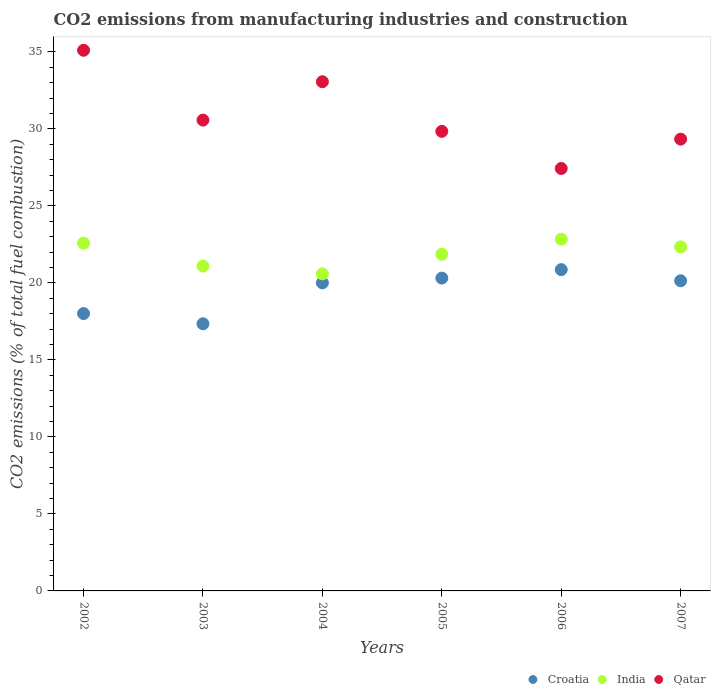How many different coloured dotlines are there?
Your answer should be very brief. 3. What is the amount of CO2 emitted in Croatia in 2002?
Provide a short and direct response. 18.01. Across all years, what is the maximum amount of CO2 emitted in Croatia?
Make the answer very short. 20.86. Across all years, what is the minimum amount of CO2 emitted in Croatia?
Your response must be concise. 17.34. What is the total amount of CO2 emitted in India in the graph?
Provide a short and direct response. 131.28. What is the difference between the amount of CO2 emitted in Qatar in 2006 and that in 2007?
Give a very brief answer. -1.91. What is the difference between the amount of CO2 emitted in India in 2004 and the amount of CO2 emitted in Qatar in 2005?
Your answer should be compact. -9.25. What is the average amount of CO2 emitted in Croatia per year?
Keep it short and to the point. 19.44. In the year 2006, what is the difference between the amount of CO2 emitted in India and amount of CO2 emitted in Croatia?
Provide a short and direct response. 1.98. In how many years, is the amount of CO2 emitted in Qatar greater than 15 %?
Provide a succinct answer. 6. What is the ratio of the amount of CO2 emitted in Qatar in 2005 to that in 2007?
Your answer should be very brief. 1.02. What is the difference between the highest and the second highest amount of CO2 emitted in India?
Your answer should be compact. 0.26. What is the difference between the highest and the lowest amount of CO2 emitted in India?
Keep it short and to the point. 2.25. Does the amount of CO2 emitted in Croatia monotonically increase over the years?
Ensure brevity in your answer.  No. How many dotlines are there?
Make the answer very short. 3. Are the values on the major ticks of Y-axis written in scientific E-notation?
Your answer should be compact. No. Does the graph contain grids?
Your answer should be very brief. No. Where does the legend appear in the graph?
Your answer should be compact. Bottom right. How many legend labels are there?
Make the answer very short. 3. How are the legend labels stacked?
Your response must be concise. Horizontal. What is the title of the graph?
Your response must be concise. CO2 emissions from manufacturing industries and construction. What is the label or title of the Y-axis?
Offer a terse response. CO2 emissions (% of total fuel combustion). What is the CO2 emissions (% of total fuel combustion) in Croatia in 2002?
Keep it short and to the point. 18.01. What is the CO2 emissions (% of total fuel combustion) of India in 2002?
Your answer should be very brief. 22.58. What is the CO2 emissions (% of total fuel combustion) in Qatar in 2002?
Your response must be concise. 35.1. What is the CO2 emissions (% of total fuel combustion) in Croatia in 2003?
Give a very brief answer. 17.34. What is the CO2 emissions (% of total fuel combustion) in India in 2003?
Provide a succinct answer. 21.09. What is the CO2 emissions (% of total fuel combustion) in Qatar in 2003?
Your response must be concise. 30.57. What is the CO2 emissions (% of total fuel combustion) of India in 2004?
Provide a short and direct response. 20.59. What is the CO2 emissions (% of total fuel combustion) in Qatar in 2004?
Give a very brief answer. 33.06. What is the CO2 emissions (% of total fuel combustion) in Croatia in 2005?
Offer a very short reply. 20.31. What is the CO2 emissions (% of total fuel combustion) in India in 2005?
Provide a short and direct response. 21.86. What is the CO2 emissions (% of total fuel combustion) in Qatar in 2005?
Your answer should be compact. 29.84. What is the CO2 emissions (% of total fuel combustion) in Croatia in 2006?
Your answer should be compact. 20.86. What is the CO2 emissions (% of total fuel combustion) in India in 2006?
Provide a succinct answer. 22.84. What is the CO2 emissions (% of total fuel combustion) in Qatar in 2006?
Your response must be concise. 27.42. What is the CO2 emissions (% of total fuel combustion) of Croatia in 2007?
Provide a succinct answer. 20.14. What is the CO2 emissions (% of total fuel combustion) in India in 2007?
Keep it short and to the point. 22.33. What is the CO2 emissions (% of total fuel combustion) of Qatar in 2007?
Provide a short and direct response. 29.33. Across all years, what is the maximum CO2 emissions (% of total fuel combustion) of Croatia?
Provide a succinct answer. 20.86. Across all years, what is the maximum CO2 emissions (% of total fuel combustion) in India?
Give a very brief answer. 22.84. Across all years, what is the maximum CO2 emissions (% of total fuel combustion) of Qatar?
Provide a short and direct response. 35.1. Across all years, what is the minimum CO2 emissions (% of total fuel combustion) in Croatia?
Provide a succinct answer. 17.34. Across all years, what is the minimum CO2 emissions (% of total fuel combustion) in India?
Provide a succinct answer. 20.59. Across all years, what is the minimum CO2 emissions (% of total fuel combustion) of Qatar?
Offer a very short reply. 27.42. What is the total CO2 emissions (% of total fuel combustion) of Croatia in the graph?
Offer a terse response. 116.65. What is the total CO2 emissions (% of total fuel combustion) in India in the graph?
Ensure brevity in your answer.  131.28. What is the total CO2 emissions (% of total fuel combustion) in Qatar in the graph?
Your answer should be very brief. 185.32. What is the difference between the CO2 emissions (% of total fuel combustion) of Croatia in 2002 and that in 2003?
Ensure brevity in your answer.  0.66. What is the difference between the CO2 emissions (% of total fuel combustion) of India in 2002 and that in 2003?
Provide a succinct answer. 1.49. What is the difference between the CO2 emissions (% of total fuel combustion) in Qatar in 2002 and that in 2003?
Ensure brevity in your answer.  4.53. What is the difference between the CO2 emissions (% of total fuel combustion) of Croatia in 2002 and that in 2004?
Offer a terse response. -1.99. What is the difference between the CO2 emissions (% of total fuel combustion) in India in 2002 and that in 2004?
Keep it short and to the point. 1.99. What is the difference between the CO2 emissions (% of total fuel combustion) of Qatar in 2002 and that in 2004?
Make the answer very short. 2.04. What is the difference between the CO2 emissions (% of total fuel combustion) of Croatia in 2002 and that in 2005?
Offer a terse response. -2.3. What is the difference between the CO2 emissions (% of total fuel combustion) in India in 2002 and that in 2005?
Offer a very short reply. 0.72. What is the difference between the CO2 emissions (% of total fuel combustion) of Qatar in 2002 and that in 2005?
Offer a very short reply. 5.27. What is the difference between the CO2 emissions (% of total fuel combustion) of Croatia in 2002 and that in 2006?
Provide a succinct answer. -2.85. What is the difference between the CO2 emissions (% of total fuel combustion) of India in 2002 and that in 2006?
Keep it short and to the point. -0.26. What is the difference between the CO2 emissions (% of total fuel combustion) of Qatar in 2002 and that in 2006?
Your answer should be compact. 7.68. What is the difference between the CO2 emissions (% of total fuel combustion) of Croatia in 2002 and that in 2007?
Offer a very short reply. -2.13. What is the difference between the CO2 emissions (% of total fuel combustion) of India in 2002 and that in 2007?
Provide a short and direct response. 0.24. What is the difference between the CO2 emissions (% of total fuel combustion) in Qatar in 2002 and that in 2007?
Your response must be concise. 5.77. What is the difference between the CO2 emissions (% of total fuel combustion) of Croatia in 2003 and that in 2004?
Make the answer very short. -2.66. What is the difference between the CO2 emissions (% of total fuel combustion) in India in 2003 and that in 2004?
Provide a succinct answer. 0.5. What is the difference between the CO2 emissions (% of total fuel combustion) of Qatar in 2003 and that in 2004?
Provide a short and direct response. -2.49. What is the difference between the CO2 emissions (% of total fuel combustion) of Croatia in 2003 and that in 2005?
Ensure brevity in your answer.  -2.97. What is the difference between the CO2 emissions (% of total fuel combustion) in India in 2003 and that in 2005?
Keep it short and to the point. -0.77. What is the difference between the CO2 emissions (% of total fuel combustion) of Qatar in 2003 and that in 2005?
Your answer should be compact. 0.73. What is the difference between the CO2 emissions (% of total fuel combustion) in Croatia in 2003 and that in 2006?
Your response must be concise. -3.51. What is the difference between the CO2 emissions (% of total fuel combustion) in India in 2003 and that in 2006?
Give a very brief answer. -1.75. What is the difference between the CO2 emissions (% of total fuel combustion) of Qatar in 2003 and that in 2006?
Keep it short and to the point. 3.14. What is the difference between the CO2 emissions (% of total fuel combustion) of Croatia in 2003 and that in 2007?
Offer a terse response. -2.79. What is the difference between the CO2 emissions (% of total fuel combustion) in India in 2003 and that in 2007?
Ensure brevity in your answer.  -1.25. What is the difference between the CO2 emissions (% of total fuel combustion) in Qatar in 2003 and that in 2007?
Your response must be concise. 1.24. What is the difference between the CO2 emissions (% of total fuel combustion) in Croatia in 2004 and that in 2005?
Ensure brevity in your answer.  -0.31. What is the difference between the CO2 emissions (% of total fuel combustion) in India in 2004 and that in 2005?
Your answer should be compact. -1.27. What is the difference between the CO2 emissions (% of total fuel combustion) of Qatar in 2004 and that in 2005?
Give a very brief answer. 3.22. What is the difference between the CO2 emissions (% of total fuel combustion) of Croatia in 2004 and that in 2006?
Your answer should be compact. -0.86. What is the difference between the CO2 emissions (% of total fuel combustion) of India in 2004 and that in 2006?
Your answer should be very brief. -2.25. What is the difference between the CO2 emissions (% of total fuel combustion) in Qatar in 2004 and that in 2006?
Ensure brevity in your answer.  5.63. What is the difference between the CO2 emissions (% of total fuel combustion) in Croatia in 2004 and that in 2007?
Your answer should be very brief. -0.14. What is the difference between the CO2 emissions (% of total fuel combustion) in India in 2004 and that in 2007?
Offer a very short reply. -1.75. What is the difference between the CO2 emissions (% of total fuel combustion) of Qatar in 2004 and that in 2007?
Your response must be concise. 3.73. What is the difference between the CO2 emissions (% of total fuel combustion) of Croatia in 2005 and that in 2006?
Ensure brevity in your answer.  -0.55. What is the difference between the CO2 emissions (% of total fuel combustion) of India in 2005 and that in 2006?
Your answer should be compact. -0.98. What is the difference between the CO2 emissions (% of total fuel combustion) in Qatar in 2005 and that in 2006?
Make the answer very short. 2.41. What is the difference between the CO2 emissions (% of total fuel combustion) of Croatia in 2005 and that in 2007?
Make the answer very short. 0.17. What is the difference between the CO2 emissions (% of total fuel combustion) of India in 2005 and that in 2007?
Provide a succinct answer. -0.48. What is the difference between the CO2 emissions (% of total fuel combustion) in Qatar in 2005 and that in 2007?
Your answer should be compact. 0.5. What is the difference between the CO2 emissions (% of total fuel combustion) of Croatia in 2006 and that in 2007?
Provide a short and direct response. 0.72. What is the difference between the CO2 emissions (% of total fuel combustion) of India in 2006 and that in 2007?
Keep it short and to the point. 0.5. What is the difference between the CO2 emissions (% of total fuel combustion) of Qatar in 2006 and that in 2007?
Provide a short and direct response. -1.91. What is the difference between the CO2 emissions (% of total fuel combustion) of Croatia in 2002 and the CO2 emissions (% of total fuel combustion) of India in 2003?
Make the answer very short. -3.08. What is the difference between the CO2 emissions (% of total fuel combustion) in Croatia in 2002 and the CO2 emissions (% of total fuel combustion) in Qatar in 2003?
Your answer should be very brief. -12.56. What is the difference between the CO2 emissions (% of total fuel combustion) in India in 2002 and the CO2 emissions (% of total fuel combustion) in Qatar in 2003?
Your response must be concise. -7.99. What is the difference between the CO2 emissions (% of total fuel combustion) in Croatia in 2002 and the CO2 emissions (% of total fuel combustion) in India in 2004?
Provide a succinct answer. -2.58. What is the difference between the CO2 emissions (% of total fuel combustion) of Croatia in 2002 and the CO2 emissions (% of total fuel combustion) of Qatar in 2004?
Make the answer very short. -15.05. What is the difference between the CO2 emissions (% of total fuel combustion) in India in 2002 and the CO2 emissions (% of total fuel combustion) in Qatar in 2004?
Keep it short and to the point. -10.48. What is the difference between the CO2 emissions (% of total fuel combustion) of Croatia in 2002 and the CO2 emissions (% of total fuel combustion) of India in 2005?
Offer a very short reply. -3.85. What is the difference between the CO2 emissions (% of total fuel combustion) in Croatia in 2002 and the CO2 emissions (% of total fuel combustion) in Qatar in 2005?
Ensure brevity in your answer.  -11.83. What is the difference between the CO2 emissions (% of total fuel combustion) in India in 2002 and the CO2 emissions (% of total fuel combustion) in Qatar in 2005?
Your response must be concise. -7.26. What is the difference between the CO2 emissions (% of total fuel combustion) in Croatia in 2002 and the CO2 emissions (% of total fuel combustion) in India in 2006?
Your answer should be very brief. -4.83. What is the difference between the CO2 emissions (% of total fuel combustion) in Croatia in 2002 and the CO2 emissions (% of total fuel combustion) in Qatar in 2006?
Your answer should be very brief. -9.42. What is the difference between the CO2 emissions (% of total fuel combustion) in India in 2002 and the CO2 emissions (% of total fuel combustion) in Qatar in 2006?
Your answer should be compact. -4.85. What is the difference between the CO2 emissions (% of total fuel combustion) of Croatia in 2002 and the CO2 emissions (% of total fuel combustion) of India in 2007?
Your response must be concise. -4.33. What is the difference between the CO2 emissions (% of total fuel combustion) of Croatia in 2002 and the CO2 emissions (% of total fuel combustion) of Qatar in 2007?
Keep it short and to the point. -11.33. What is the difference between the CO2 emissions (% of total fuel combustion) in India in 2002 and the CO2 emissions (% of total fuel combustion) in Qatar in 2007?
Give a very brief answer. -6.75. What is the difference between the CO2 emissions (% of total fuel combustion) in Croatia in 2003 and the CO2 emissions (% of total fuel combustion) in India in 2004?
Offer a very short reply. -3.24. What is the difference between the CO2 emissions (% of total fuel combustion) of Croatia in 2003 and the CO2 emissions (% of total fuel combustion) of Qatar in 2004?
Your response must be concise. -15.71. What is the difference between the CO2 emissions (% of total fuel combustion) in India in 2003 and the CO2 emissions (% of total fuel combustion) in Qatar in 2004?
Ensure brevity in your answer.  -11.97. What is the difference between the CO2 emissions (% of total fuel combustion) of Croatia in 2003 and the CO2 emissions (% of total fuel combustion) of India in 2005?
Offer a very short reply. -4.51. What is the difference between the CO2 emissions (% of total fuel combustion) in Croatia in 2003 and the CO2 emissions (% of total fuel combustion) in Qatar in 2005?
Provide a short and direct response. -12.49. What is the difference between the CO2 emissions (% of total fuel combustion) in India in 2003 and the CO2 emissions (% of total fuel combustion) in Qatar in 2005?
Your response must be concise. -8.75. What is the difference between the CO2 emissions (% of total fuel combustion) in Croatia in 2003 and the CO2 emissions (% of total fuel combustion) in India in 2006?
Provide a succinct answer. -5.49. What is the difference between the CO2 emissions (% of total fuel combustion) of Croatia in 2003 and the CO2 emissions (% of total fuel combustion) of Qatar in 2006?
Offer a very short reply. -10.08. What is the difference between the CO2 emissions (% of total fuel combustion) of India in 2003 and the CO2 emissions (% of total fuel combustion) of Qatar in 2006?
Keep it short and to the point. -6.34. What is the difference between the CO2 emissions (% of total fuel combustion) in Croatia in 2003 and the CO2 emissions (% of total fuel combustion) in India in 2007?
Your answer should be very brief. -4.99. What is the difference between the CO2 emissions (% of total fuel combustion) of Croatia in 2003 and the CO2 emissions (% of total fuel combustion) of Qatar in 2007?
Make the answer very short. -11.99. What is the difference between the CO2 emissions (% of total fuel combustion) of India in 2003 and the CO2 emissions (% of total fuel combustion) of Qatar in 2007?
Your answer should be compact. -8.24. What is the difference between the CO2 emissions (% of total fuel combustion) of Croatia in 2004 and the CO2 emissions (% of total fuel combustion) of India in 2005?
Offer a very short reply. -1.86. What is the difference between the CO2 emissions (% of total fuel combustion) in Croatia in 2004 and the CO2 emissions (% of total fuel combustion) in Qatar in 2005?
Give a very brief answer. -9.84. What is the difference between the CO2 emissions (% of total fuel combustion) of India in 2004 and the CO2 emissions (% of total fuel combustion) of Qatar in 2005?
Your answer should be very brief. -9.25. What is the difference between the CO2 emissions (% of total fuel combustion) in Croatia in 2004 and the CO2 emissions (% of total fuel combustion) in India in 2006?
Ensure brevity in your answer.  -2.84. What is the difference between the CO2 emissions (% of total fuel combustion) of Croatia in 2004 and the CO2 emissions (% of total fuel combustion) of Qatar in 2006?
Your answer should be very brief. -7.42. What is the difference between the CO2 emissions (% of total fuel combustion) in India in 2004 and the CO2 emissions (% of total fuel combustion) in Qatar in 2006?
Your response must be concise. -6.84. What is the difference between the CO2 emissions (% of total fuel combustion) of Croatia in 2004 and the CO2 emissions (% of total fuel combustion) of India in 2007?
Ensure brevity in your answer.  -2.33. What is the difference between the CO2 emissions (% of total fuel combustion) of Croatia in 2004 and the CO2 emissions (% of total fuel combustion) of Qatar in 2007?
Your answer should be compact. -9.33. What is the difference between the CO2 emissions (% of total fuel combustion) in India in 2004 and the CO2 emissions (% of total fuel combustion) in Qatar in 2007?
Provide a succinct answer. -8.75. What is the difference between the CO2 emissions (% of total fuel combustion) of Croatia in 2005 and the CO2 emissions (% of total fuel combustion) of India in 2006?
Provide a succinct answer. -2.53. What is the difference between the CO2 emissions (% of total fuel combustion) of Croatia in 2005 and the CO2 emissions (% of total fuel combustion) of Qatar in 2006?
Ensure brevity in your answer.  -7.12. What is the difference between the CO2 emissions (% of total fuel combustion) of India in 2005 and the CO2 emissions (% of total fuel combustion) of Qatar in 2006?
Your answer should be very brief. -5.57. What is the difference between the CO2 emissions (% of total fuel combustion) of Croatia in 2005 and the CO2 emissions (% of total fuel combustion) of India in 2007?
Give a very brief answer. -2.03. What is the difference between the CO2 emissions (% of total fuel combustion) of Croatia in 2005 and the CO2 emissions (% of total fuel combustion) of Qatar in 2007?
Your answer should be very brief. -9.02. What is the difference between the CO2 emissions (% of total fuel combustion) in India in 2005 and the CO2 emissions (% of total fuel combustion) in Qatar in 2007?
Make the answer very short. -7.47. What is the difference between the CO2 emissions (% of total fuel combustion) of Croatia in 2006 and the CO2 emissions (% of total fuel combustion) of India in 2007?
Offer a very short reply. -1.48. What is the difference between the CO2 emissions (% of total fuel combustion) in Croatia in 2006 and the CO2 emissions (% of total fuel combustion) in Qatar in 2007?
Provide a short and direct response. -8.47. What is the difference between the CO2 emissions (% of total fuel combustion) in India in 2006 and the CO2 emissions (% of total fuel combustion) in Qatar in 2007?
Keep it short and to the point. -6.5. What is the average CO2 emissions (% of total fuel combustion) of Croatia per year?
Offer a terse response. 19.44. What is the average CO2 emissions (% of total fuel combustion) in India per year?
Ensure brevity in your answer.  21.88. What is the average CO2 emissions (% of total fuel combustion) of Qatar per year?
Your answer should be compact. 30.89. In the year 2002, what is the difference between the CO2 emissions (% of total fuel combustion) in Croatia and CO2 emissions (% of total fuel combustion) in India?
Give a very brief answer. -4.57. In the year 2002, what is the difference between the CO2 emissions (% of total fuel combustion) in Croatia and CO2 emissions (% of total fuel combustion) in Qatar?
Offer a very short reply. -17.1. In the year 2002, what is the difference between the CO2 emissions (% of total fuel combustion) of India and CO2 emissions (% of total fuel combustion) of Qatar?
Make the answer very short. -12.52. In the year 2003, what is the difference between the CO2 emissions (% of total fuel combustion) of Croatia and CO2 emissions (% of total fuel combustion) of India?
Your answer should be compact. -3.74. In the year 2003, what is the difference between the CO2 emissions (% of total fuel combustion) in Croatia and CO2 emissions (% of total fuel combustion) in Qatar?
Offer a very short reply. -13.22. In the year 2003, what is the difference between the CO2 emissions (% of total fuel combustion) in India and CO2 emissions (% of total fuel combustion) in Qatar?
Make the answer very short. -9.48. In the year 2004, what is the difference between the CO2 emissions (% of total fuel combustion) in Croatia and CO2 emissions (% of total fuel combustion) in India?
Provide a succinct answer. -0.59. In the year 2004, what is the difference between the CO2 emissions (% of total fuel combustion) of Croatia and CO2 emissions (% of total fuel combustion) of Qatar?
Your answer should be very brief. -13.06. In the year 2004, what is the difference between the CO2 emissions (% of total fuel combustion) in India and CO2 emissions (% of total fuel combustion) in Qatar?
Your answer should be compact. -12.47. In the year 2005, what is the difference between the CO2 emissions (% of total fuel combustion) of Croatia and CO2 emissions (% of total fuel combustion) of India?
Offer a very short reply. -1.55. In the year 2005, what is the difference between the CO2 emissions (% of total fuel combustion) in Croatia and CO2 emissions (% of total fuel combustion) in Qatar?
Provide a short and direct response. -9.53. In the year 2005, what is the difference between the CO2 emissions (% of total fuel combustion) in India and CO2 emissions (% of total fuel combustion) in Qatar?
Provide a short and direct response. -7.98. In the year 2006, what is the difference between the CO2 emissions (% of total fuel combustion) of Croatia and CO2 emissions (% of total fuel combustion) of India?
Provide a short and direct response. -1.98. In the year 2006, what is the difference between the CO2 emissions (% of total fuel combustion) in Croatia and CO2 emissions (% of total fuel combustion) in Qatar?
Offer a terse response. -6.57. In the year 2006, what is the difference between the CO2 emissions (% of total fuel combustion) of India and CO2 emissions (% of total fuel combustion) of Qatar?
Give a very brief answer. -4.59. In the year 2007, what is the difference between the CO2 emissions (% of total fuel combustion) of Croatia and CO2 emissions (% of total fuel combustion) of India?
Provide a succinct answer. -2.2. In the year 2007, what is the difference between the CO2 emissions (% of total fuel combustion) of Croatia and CO2 emissions (% of total fuel combustion) of Qatar?
Make the answer very short. -9.2. In the year 2007, what is the difference between the CO2 emissions (% of total fuel combustion) in India and CO2 emissions (% of total fuel combustion) in Qatar?
Provide a short and direct response. -7. What is the ratio of the CO2 emissions (% of total fuel combustion) in Croatia in 2002 to that in 2003?
Your answer should be very brief. 1.04. What is the ratio of the CO2 emissions (% of total fuel combustion) in India in 2002 to that in 2003?
Provide a succinct answer. 1.07. What is the ratio of the CO2 emissions (% of total fuel combustion) in Qatar in 2002 to that in 2003?
Offer a terse response. 1.15. What is the ratio of the CO2 emissions (% of total fuel combustion) in Croatia in 2002 to that in 2004?
Provide a short and direct response. 0.9. What is the ratio of the CO2 emissions (% of total fuel combustion) of India in 2002 to that in 2004?
Give a very brief answer. 1.1. What is the ratio of the CO2 emissions (% of total fuel combustion) of Qatar in 2002 to that in 2004?
Provide a succinct answer. 1.06. What is the ratio of the CO2 emissions (% of total fuel combustion) of Croatia in 2002 to that in 2005?
Offer a very short reply. 0.89. What is the ratio of the CO2 emissions (% of total fuel combustion) in India in 2002 to that in 2005?
Your answer should be compact. 1.03. What is the ratio of the CO2 emissions (% of total fuel combustion) in Qatar in 2002 to that in 2005?
Offer a very short reply. 1.18. What is the ratio of the CO2 emissions (% of total fuel combustion) of Croatia in 2002 to that in 2006?
Keep it short and to the point. 0.86. What is the ratio of the CO2 emissions (% of total fuel combustion) of India in 2002 to that in 2006?
Your answer should be compact. 0.99. What is the ratio of the CO2 emissions (% of total fuel combustion) in Qatar in 2002 to that in 2006?
Ensure brevity in your answer.  1.28. What is the ratio of the CO2 emissions (% of total fuel combustion) of Croatia in 2002 to that in 2007?
Provide a succinct answer. 0.89. What is the ratio of the CO2 emissions (% of total fuel combustion) of India in 2002 to that in 2007?
Your response must be concise. 1.01. What is the ratio of the CO2 emissions (% of total fuel combustion) of Qatar in 2002 to that in 2007?
Keep it short and to the point. 1.2. What is the ratio of the CO2 emissions (% of total fuel combustion) in Croatia in 2003 to that in 2004?
Your response must be concise. 0.87. What is the ratio of the CO2 emissions (% of total fuel combustion) in India in 2003 to that in 2004?
Make the answer very short. 1.02. What is the ratio of the CO2 emissions (% of total fuel combustion) of Qatar in 2003 to that in 2004?
Provide a short and direct response. 0.92. What is the ratio of the CO2 emissions (% of total fuel combustion) in Croatia in 2003 to that in 2005?
Provide a succinct answer. 0.85. What is the ratio of the CO2 emissions (% of total fuel combustion) of India in 2003 to that in 2005?
Your response must be concise. 0.96. What is the ratio of the CO2 emissions (% of total fuel combustion) in Qatar in 2003 to that in 2005?
Provide a succinct answer. 1.02. What is the ratio of the CO2 emissions (% of total fuel combustion) of Croatia in 2003 to that in 2006?
Keep it short and to the point. 0.83. What is the ratio of the CO2 emissions (% of total fuel combustion) in India in 2003 to that in 2006?
Give a very brief answer. 0.92. What is the ratio of the CO2 emissions (% of total fuel combustion) in Qatar in 2003 to that in 2006?
Ensure brevity in your answer.  1.11. What is the ratio of the CO2 emissions (% of total fuel combustion) in Croatia in 2003 to that in 2007?
Your response must be concise. 0.86. What is the ratio of the CO2 emissions (% of total fuel combustion) of India in 2003 to that in 2007?
Your answer should be very brief. 0.94. What is the ratio of the CO2 emissions (% of total fuel combustion) in Qatar in 2003 to that in 2007?
Offer a very short reply. 1.04. What is the ratio of the CO2 emissions (% of total fuel combustion) in Croatia in 2004 to that in 2005?
Ensure brevity in your answer.  0.98. What is the ratio of the CO2 emissions (% of total fuel combustion) in India in 2004 to that in 2005?
Offer a terse response. 0.94. What is the ratio of the CO2 emissions (% of total fuel combustion) of Qatar in 2004 to that in 2005?
Offer a very short reply. 1.11. What is the ratio of the CO2 emissions (% of total fuel combustion) of Croatia in 2004 to that in 2006?
Your answer should be compact. 0.96. What is the ratio of the CO2 emissions (% of total fuel combustion) of India in 2004 to that in 2006?
Your answer should be very brief. 0.9. What is the ratio of the CO2 emissions (% of total fuel combustion) of Qatar in 2004 to that in 2006?
Your response must be concise. 1.21. What is the ratio of the CO2 emissions (% of total fuel combustion) in India in 2004 to that in 2007?
Provide a succinct answer. 0.92. What is the ratio of the CO2 emissions (% of total fuel combustion) of Qatar in 2004 to that in 2007?
Offer a terse response. 1.13. What is the ratio of the CO2 emissions (% of total fuel combustion) of Croatia in 2005 to that in 2006?
Offer a terse response. 0.97. What is the ratio of the CO2 emissions (% of total fuel combustion) in India in 2005 to that in 2006?
Provide a short and direct response. 0.96. What is the ratio of the CO2 emissions (% of total fuel combustion) of Qatar in 2005 to that in 2006?
Give a very brief answer. 1.09. What is the ratio of the CO2 emissions (% of total fuel combustion) of Croatia in 2005 to that in 2007?
Offer a terse response. 1.01. What is the ratio of the CO2 emissions (% of total fuel combustion) of India in 2005 to that in 2007?
Give a very brief answer. 0.98. What is the ratio of the CO2 emissions (% of total fuel combustion) of Qatar in 2005 to that in 2007?
Your answer should be compact. 1.02. What is the ratio of the CO2 emissions (% of total fuel combustion) of Croatia in 2006 to that in 2007?
Offer a very short reply. 1.04. What is the ratio of the CO2 emissions (% of total fuel combustion) in India in 2006 to that in 2007?
Make the answer very short. 1.02. What is the ratio of the CO2 emissions (% of total fuel combustion) in Qatar in 2006 to that in 2007?
Provide a short and direct response. 0.94. What is the difference between the highest and the second highest CO2 emissions (% of total fuel combustion) of Croatia?
Your answer should be compact. 0.55. What is the difference between the highest and the second highest CO2 emissions (% of total fuel combustion) in India?
Provide a succinct answer. 0.26. What is the difference between the highest and the second highest CO2 emissions (% of total fuel combustion) of Qatar?
Ensure brevity in your answer.  2.04. What is the difference between the highest and the lowest CO2 emissions (% of total fuel combustion) in Croatia?
Offer a very short reply. 3.51. What is the difference between the highest and the lowest CO2 emissions (% of total fuel combustion) in India?
Offer a terse response. 2.25. What is the difference between the highest and the lowest CO2 emissions (% of total fuel combustion) of Qatar?
Ensure brevity in your answer.  7.68. 